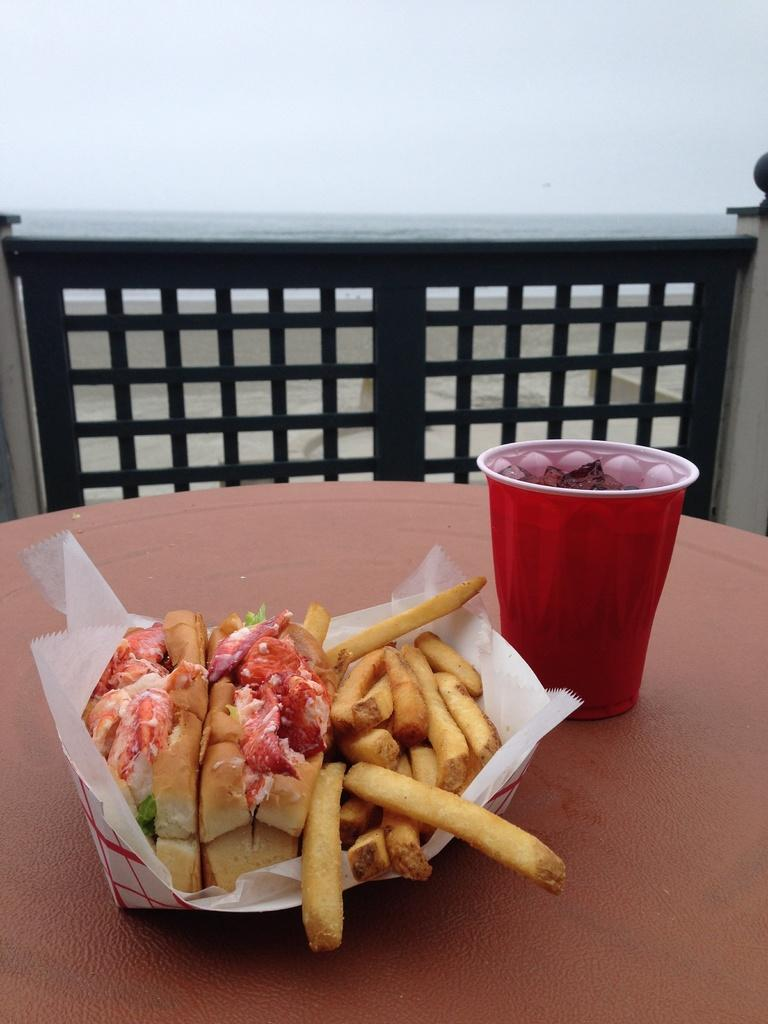What type of items can be seen in the image? There are food items in the image. What is the color and content of the cup in the image? There is a red color cup with a drink in it. Where are the cup and food items placed? The cup and food items are placed on a table. What can be seen in the background of the image? There is railing and a white color wall visible in the background of the image. What type of authority is depicted in the image? There is no authority figure present in the image; it features food items, a red cup with a drink, and a background with railing and a white wall. How many units of food items are visible in the image? The number of food items cannot be determined from the image alone, as it only shows a general presence of food items without specifying the exact quantity. 